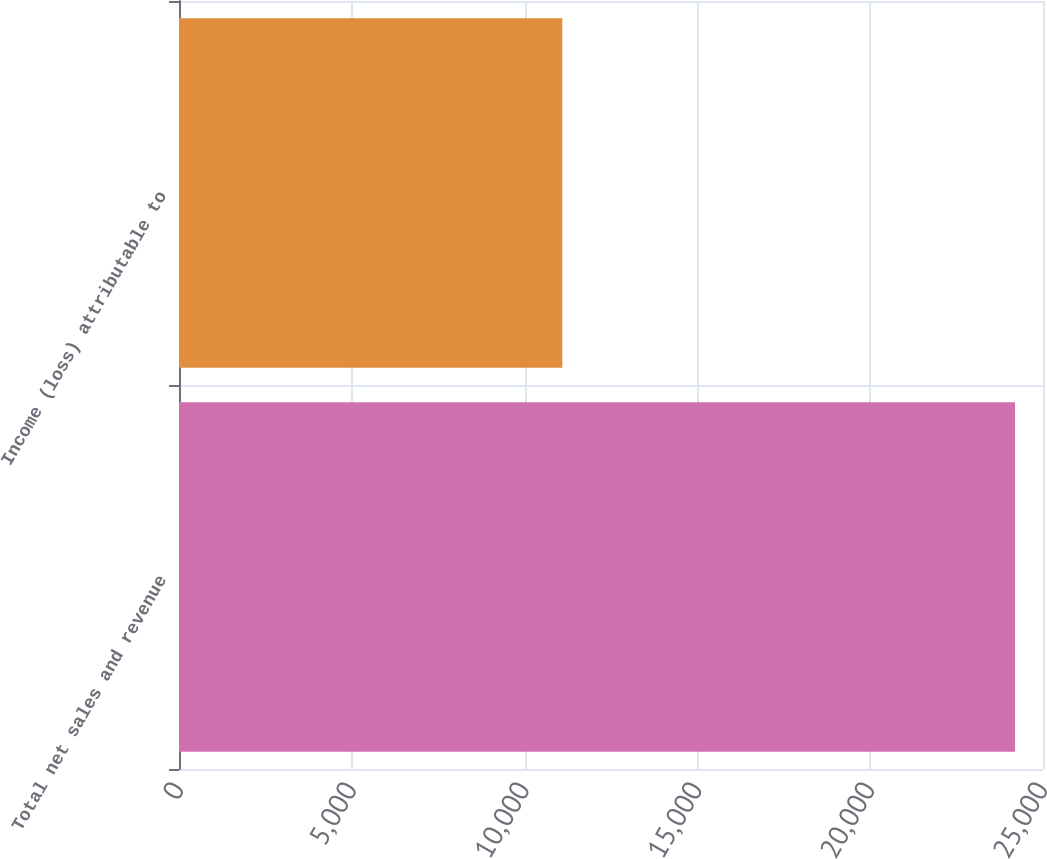Convert chart to OTSL. <chart><loc_0><loc_0><loc_500><loc_500><bar_chart><fcel>Total net sales and revenue<fcel>Income (loss) attributable to<nl><fcel>24191<fcel>11092<nl></chart> 